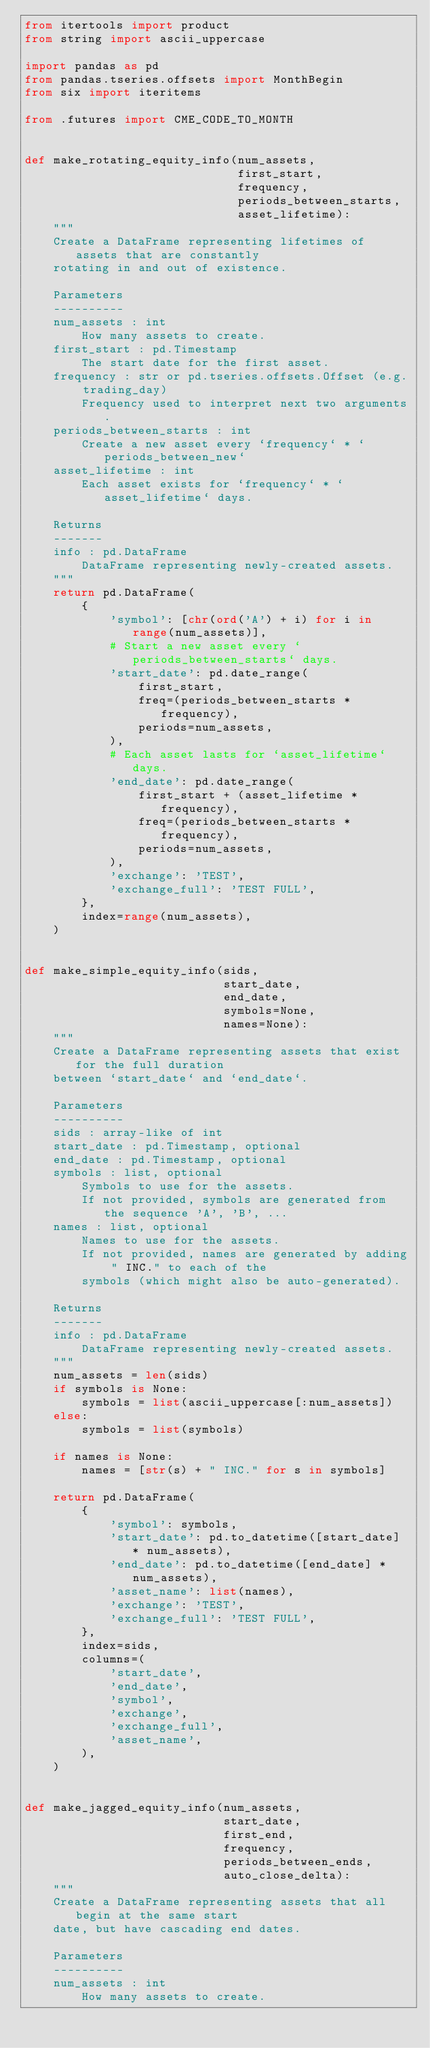Convert code to text. <code><loc_0><loc_0><loc_500><loc_500><_Python_>from itertools import product
from string import ascii_uppercase

import pandas as pd
from pandas.tseries.offsets import MonthBegin
from six import iteritems

from .futures import CME_CODE_TO_MONTH


def make_rotating_equity_info(num_assets,
                              first_start,
                              frequency,
                              periods_between_starts,
                              asset_lifetime):
    """
    Create a DataFrame representing lifetimes of assets that are constantly
    rotating in and out of existence.

    Parameters
    ----------
    num_assets : int
        How many assets to create.
    first_start : pd.Timestamp
        The start date for the first asset.
    frequency : str or pd.tseries.offsets.Offset (e.g. trading_day)
        Frequency used to interpret next two arguments.
    periods_between_starts : int
        Create a new asset every `frequency` * `periods_between_new`
    asset_lifetime : int
        Each asset exists for `frequency` * `asset_lifetime` days.

    Returns
    -------
    info : pd.DataFrame
        DataFrame representing newly-created assets.
    """
    return pd.DataFrame(
        {
            'symbol': [chr(ord('A') + i) for i in range(num_assets)],
            # Start a new asset every `periods_between_starts` days.
            'start_date': pd.date_range(
                first_start,
                freq=(periods_between_starts * frequency),
                periods=num_assets,
            ),
            # Each asset lasts for `asset_lifetime` days.
            'end_date': pd.date_range(
                first_start + (asset_lifetime * frequency),
                freq=(periods_between_starts * frequency),
                periods=num_assets,
            ),
            'exchange': 'TEST',
            'exchange_full': 'TEST FULL',
        },
        index=range(num_assets),
    )


def make_simple_equity_info(sids,
                            start_date,
                            end_date,
                            symbols=None,
                            names=None):
    """
    Create a DataFrame representing assets that exist for the full duration
    between `start_date` and `end_date`.

    Parameters
    ----------
    sids : array-like of int
    start_date : pd.Timestamp, optional
    end_date : pd.Timestamp, optional
    symbols : list, optional
        Symbols to use for the assets.
        If not provided, symbols are generated from the sequence 'A', 'B', ...
    names : list, optional
        Names to use for the assets.
        If not provided, names are generated by adding " INC." to each of the
        symbols (which might also be auto-generated).

    Returns
    -------
    info : pd.DataFrame
        DataFrame representing newly-created assets.
    """
    num_assets = len(sids)
    if symbols is None:
        symbols = list(ascii_uppercase[:num_assets])
    else:
        symbols = list(symbols)

    if names is None:
        names = [str(s) + " INC." for s in symbols]

    return pd.DataFrame(
        {
            'symbol': symbols,
            'start_date': pd.to_datetime([start_date] * num_assets),
            'end_date': pd.to_datetime([end_date] * num_assets),
            'asset_name': list(names),
            'exchange': 'TEST',
            'exchange_full': 'TEST FULL',
        },
        index=sids,
        columns=(
            'start_date',
            'end_date',
            'symbol',
            'exchange',
            'exchange_full',
            'asset_name',
        ),
    )


def make_jagged_equity_info(num_assets,
                            start_date,
                            first_end,
                            frequency,
                            periods_between_ends,
                            auto_close_delta):
    """
    Create a DataFrame representing assets that all begin at the same start
    date, but have cascading end dates.

    Parameters
    ----------
    num_assets : int
        How many assets to create.</code> 